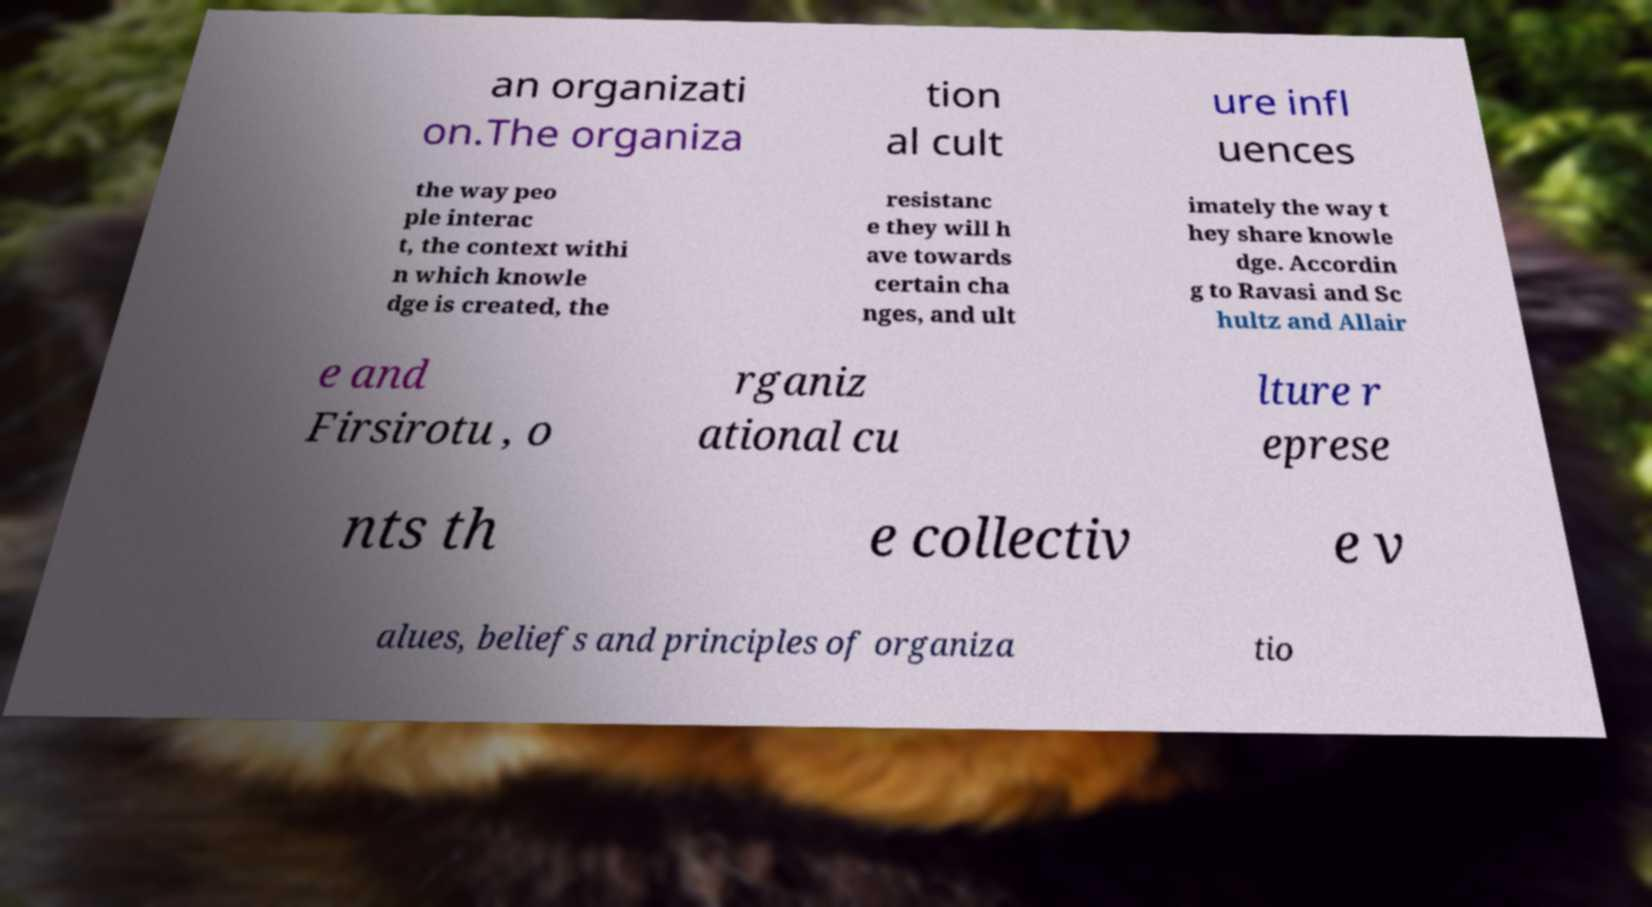For documentation purposes, I need the text within this image transcribed. Could you provide that? an organizati on.The organiza tion al cult ure infl uences the way peo ple interac t, the context withi n which knowle dge is created, the resistanc e they will h ave towards certain cha nges, and ult imately the way t hey share knowle dge. Accordin g to Ravasi and Sc hultz and Allair e and Firsirotu , o rganiz ational cu lture r eprese nts th e collectiv e v alues, beliefs and principles of organiza tio 